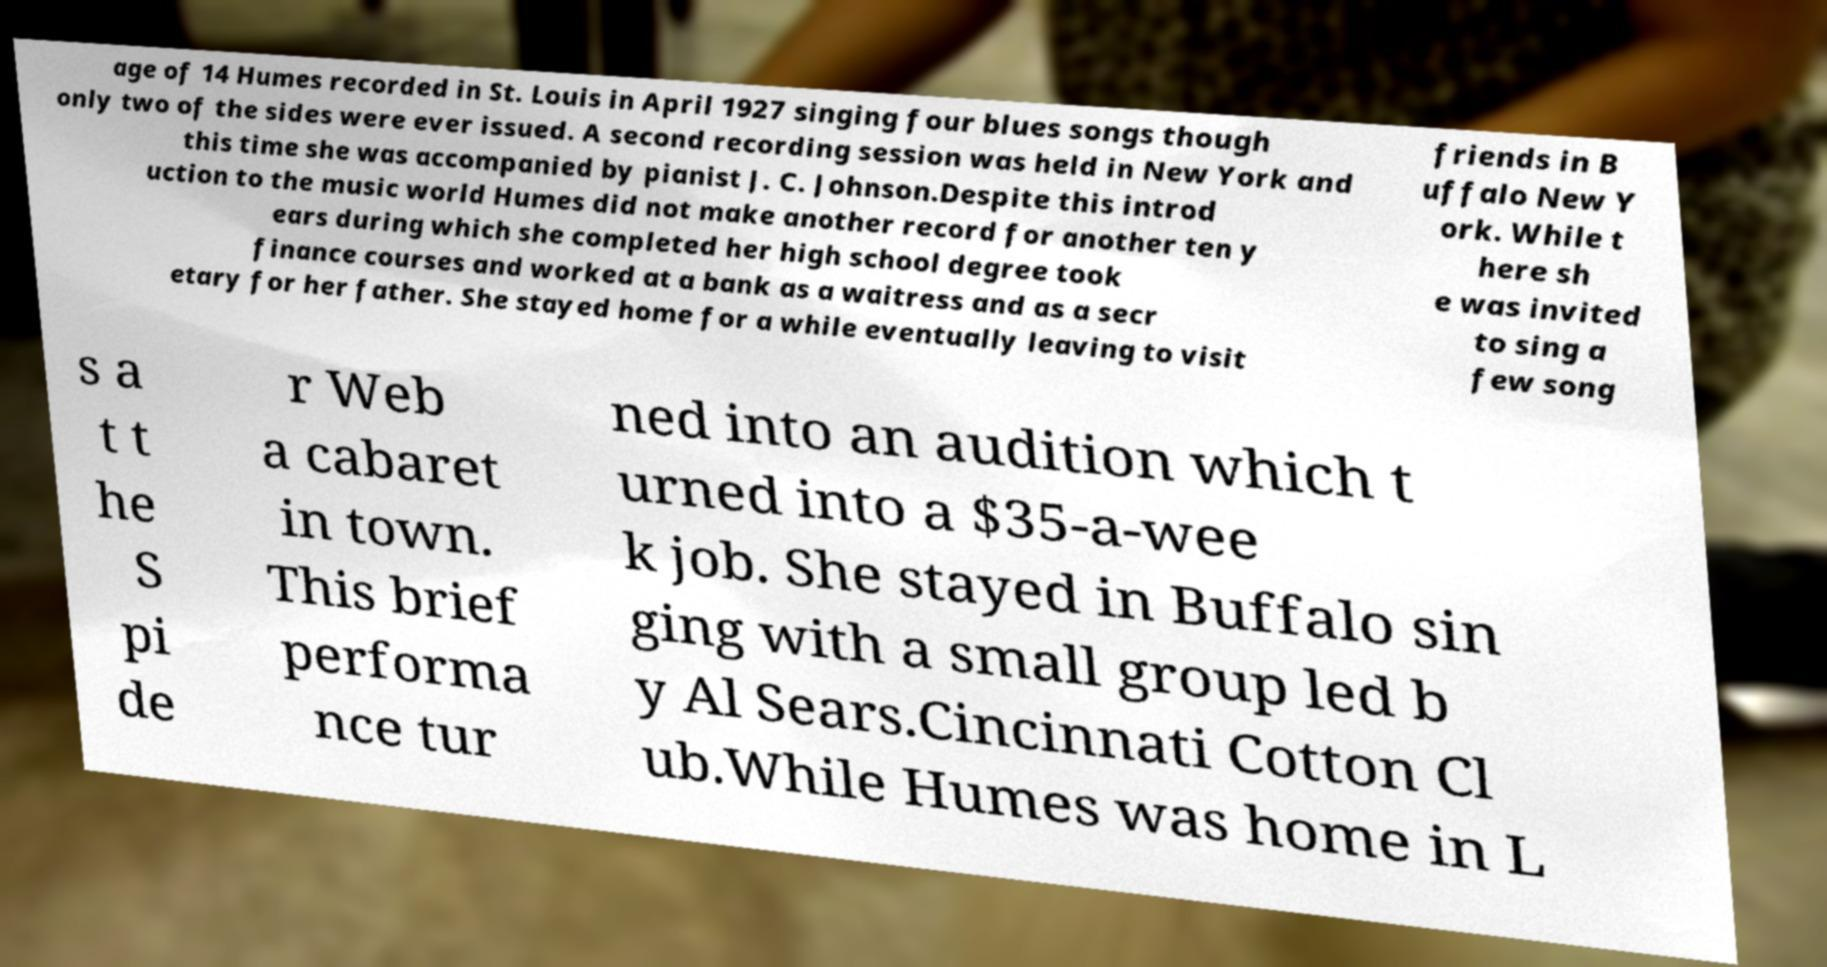Can you read and provide the text displayed in the image?This photo seems to have some interesting text. Can you extract and type it out for me? age of 14 Humes recorded in St. Louis in April 1927 singing four blues songs though only two of the sides were ever issued. A second recording session was held in New York and this time she was accompanied by pianist J. C. Johnson.Despite this introd uction to the music world Humes did not make another record for another ten y ears during which she completed her high school degree took finance courses and worked at a bank as a waitress and as a secr etary for her father. She stayed home for a while eventually leaving to visit friends in B uffalo New Y ork. While t here sh e was invited to sing a few song s a t t he S pi de r Web a cabaret in town. This brief performa nce tur ned into an audition which t urned into a $35-a-wee k job. She stayed in Buffalo sin ging with a small group led b y Al Sears.Cincinnati Cotton Cl ub.While Humes was home in L 